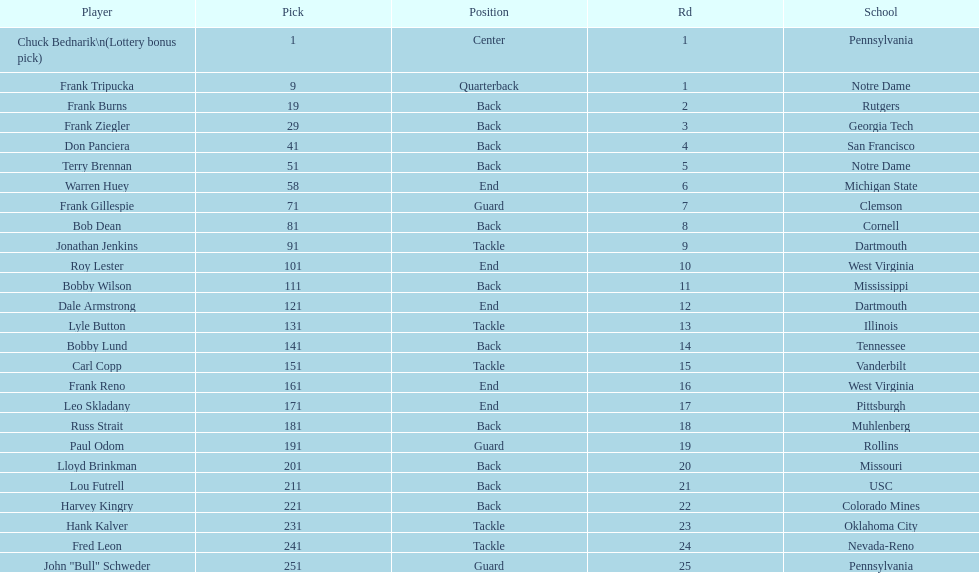Highest rd number? 25. I'm looking to parse the entire table for insights. Could you assist me with that? {'header': ['Player', 'Pick', 'Position', 'Rd', 'School'], 'rows': [['Chuck Bednarik\\n(Lottery bonus pick)', '1', 'Center', '1', 'Pennsylvania'], ['Frank Tripucka', '9', 'Quarterback', '1', 'Notre Dame'], ['Frank Burns', '19', 'Back', '2', 'Rutgers'], ['Frank Ziegler', '29', 'Back', '3', 'Georgia Tech'], ['Don Panciera', '41', 'Back', '4', 'San Francisco'], ['Terry Brennan', '51', 'Back', '5', 'Notre Dame'], ['Warren Huey', '58', 'End', '6', 'Michigan State'], ['Frank Gillespie', '71', 'Guard', '7', 'Clemson'], ['Bob Dean', '81', 'Back', '8', 'Cornell'], ['Jonathan Jenkins', '91', 'Tackle', '9', 'Dartmouth'], ['Roy Lester', '101', 'End', '10', 'West Virginia'], ['Bobby Wilson', '111', 'Back', '11', 'Mississippi'], ['Dale Armstrong', '121', 'End', '12', 'Dartmouth'], ['Lyle Button', '131', 'Tackle', '13', 'Illinois'], ['Bobby Lund', '141', 'Back', '14', 'Tennessee'], ['Carl Copp', '151', 'Tackle', '15', 'Vanderbilt'], ['Frank Reno', '161', 'End', '16', 'West Virginia'], ['Leo Skladany', '171', 'End', '17', 'Pittsburgh'], ['Russ Strait', '181', 'Back', '18', 'Muhlenberg'], ['Paul Odom', '191', 'Guard', '19', 'Rollins'], ['Lloyd Brinkman', '201', 'Back', '20', 'Missouri'], ['Lou Futrell', '211', 'Back', '21', 'USC'], ['Harvey Kingry', '221', 'Back', '22', 'Colorado Mines'], ['Hank Kalver', '231', 'Tackle', '23', 'Oklahoma City'], ['Fred Leon', '241', 'Tackle', '24', 'Nevada-Reno'], ['John "Bull" Schweder', '251', 'Guard', '25', 'Pennsylvania']]} 